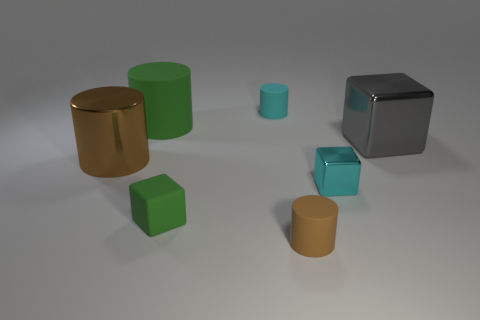Is the number of matte cylinders less than the number of cyan matte cylinders? Actually, there are two matte cylinders and only one cylinder that is cyan and has a matte texture, making the number of matte cylinders greater than the number of cyan matte cylinders. 